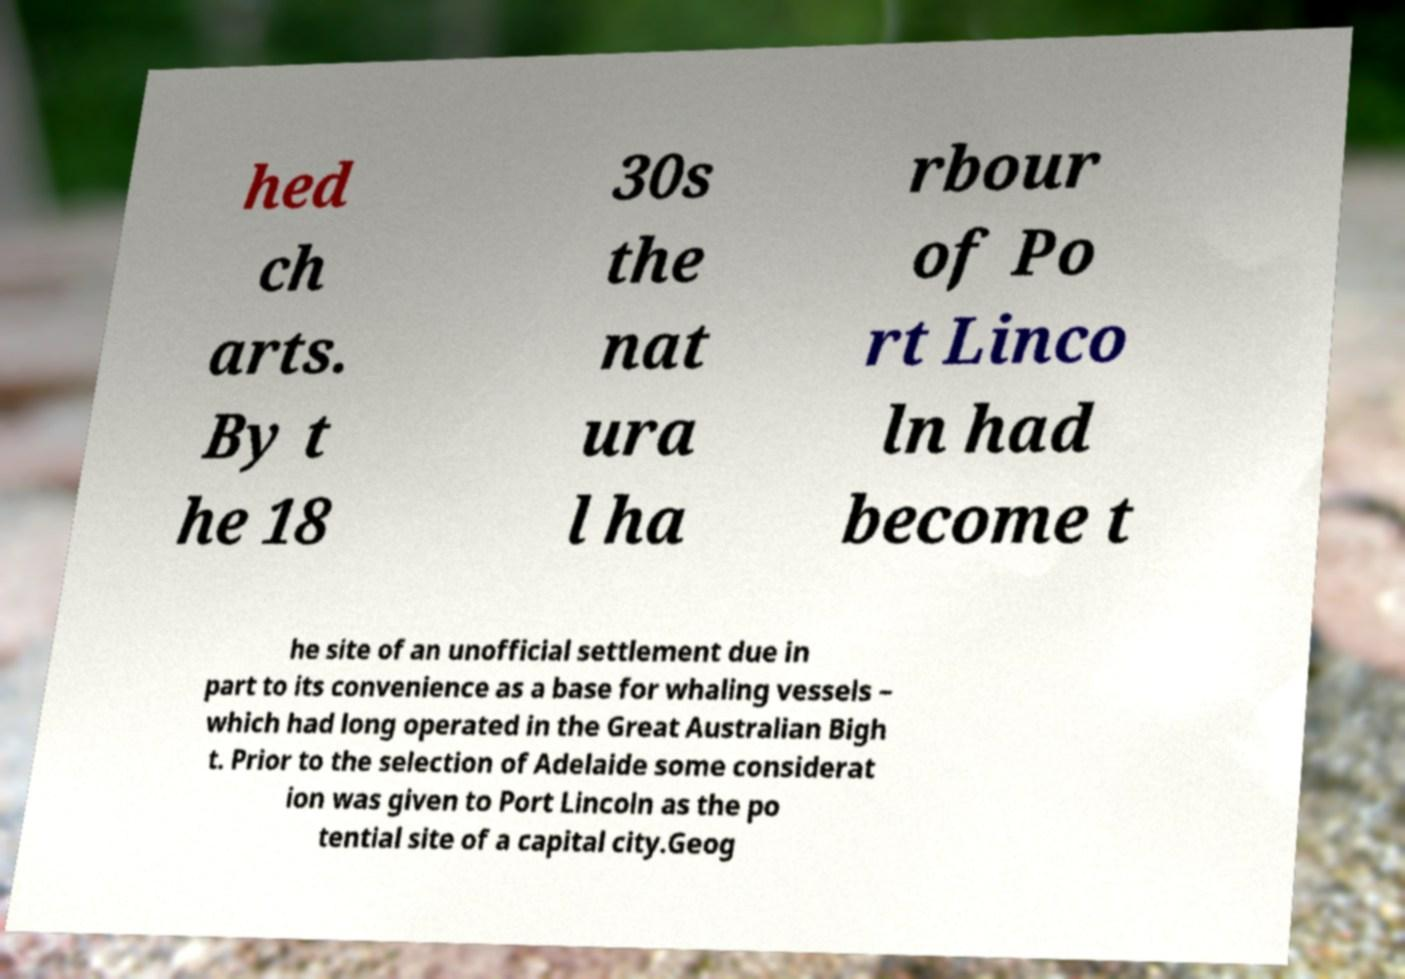Could you extract and type out the text from this image? hed ch arts. By t he 18 30s the nat ura l ha rbour of Po rt Linco ln had become t he site of an unofficial settlement due in part to its convenience as a base for whaling vessels – which had long operated in the Great Australian Bigh t. Prior to the selection of Adelaide some considerat ion was given to Port Lincoln as the po tential site of a capital city.Geog 